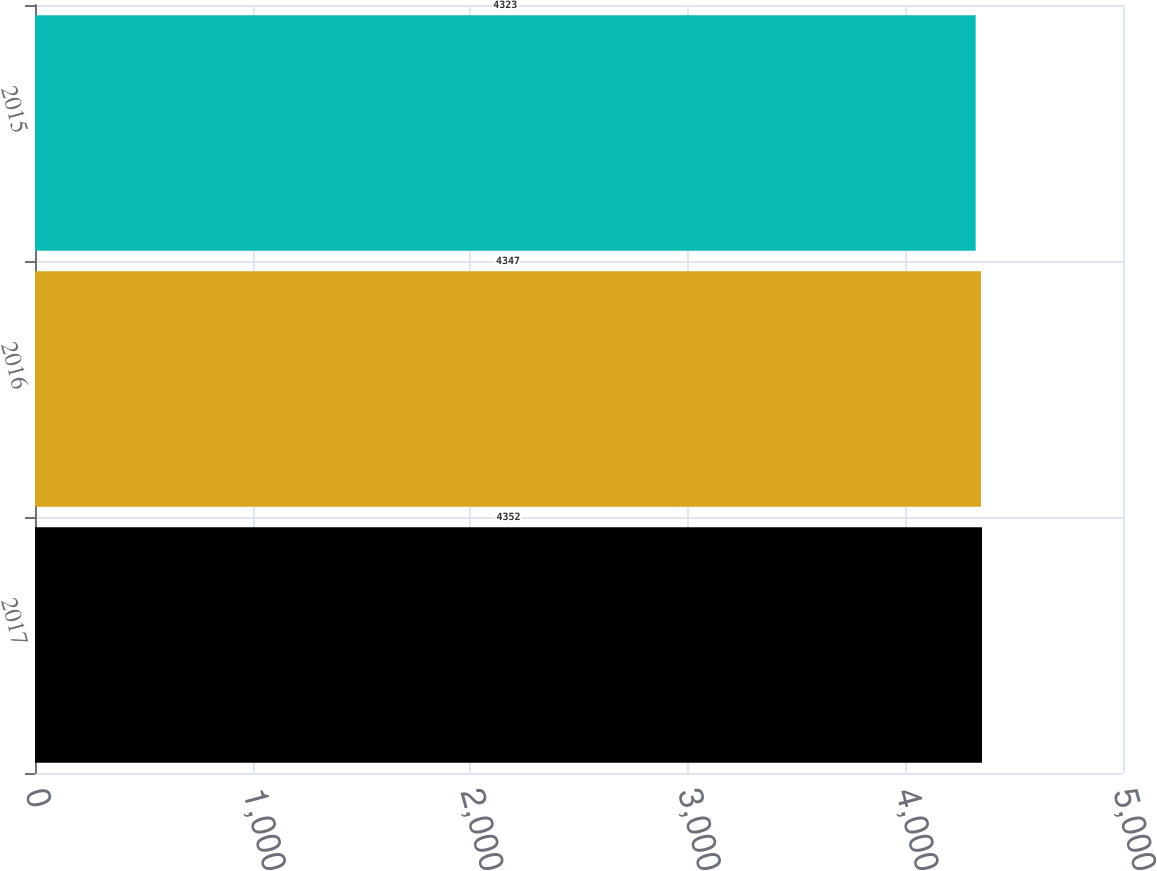<chart> <loc_0><loc_0><loc_500><loc_500><bar_chart><fcel>2017<fcel>2016<fcel>2015<nl><fcel>4352<fcel>4347<fcel>4323<nl></chart> 